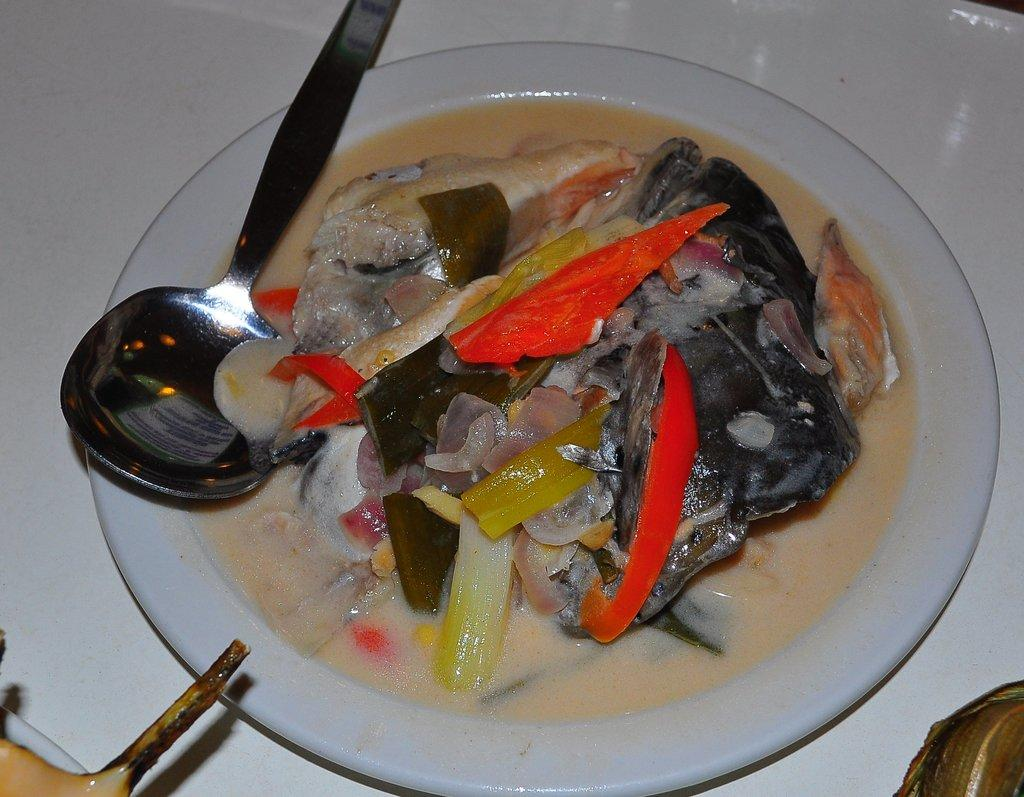What is on the plate that is visible in the image? There is a plate with food items in the image. What utensil is present in the image? There is a spoon in the image. What type of food can be seen on the plate? There are vegetables in the image. Can you describe any other objects that might be on the table in the image? The image may contain other objects on the table, but the provided facts do not specify what they are. Where might this image have been taken? The image is likely taken in a room, as there is a table and other objects present. What type of stamp can be seen on the vegetables in the image? There is no stamp present on the vegetables in the image. Can you see a giraffe in the background of the image? There is no giraffe present in the image. 